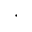Convert formula to latex. <formula><loc_0><loc_0><loc_500><loc_500>\cdot</formula> 